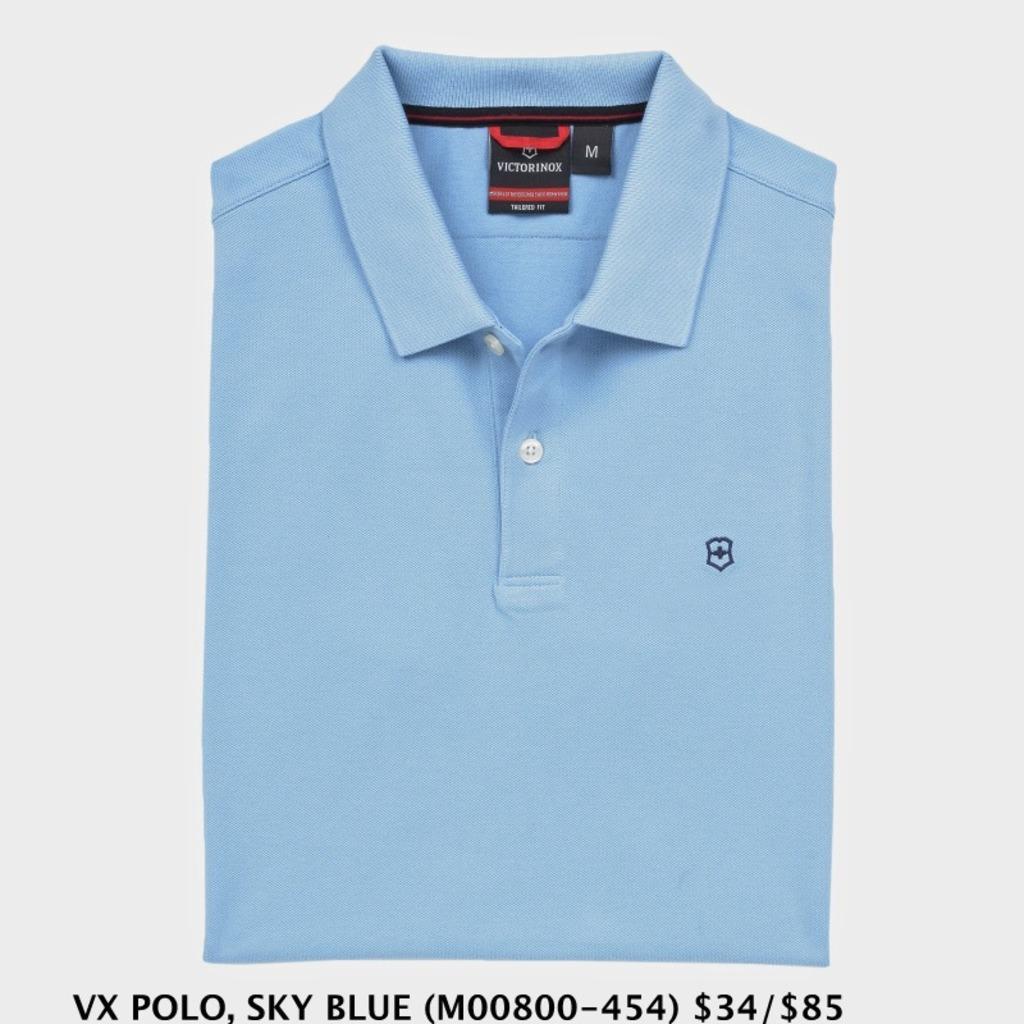Can you describe this image briefly? In the image there is a blue color folded t-shirt with a size and brand tag on it. Below the t-shirt there is a brand, color and rate of the t-shirt on the image. 